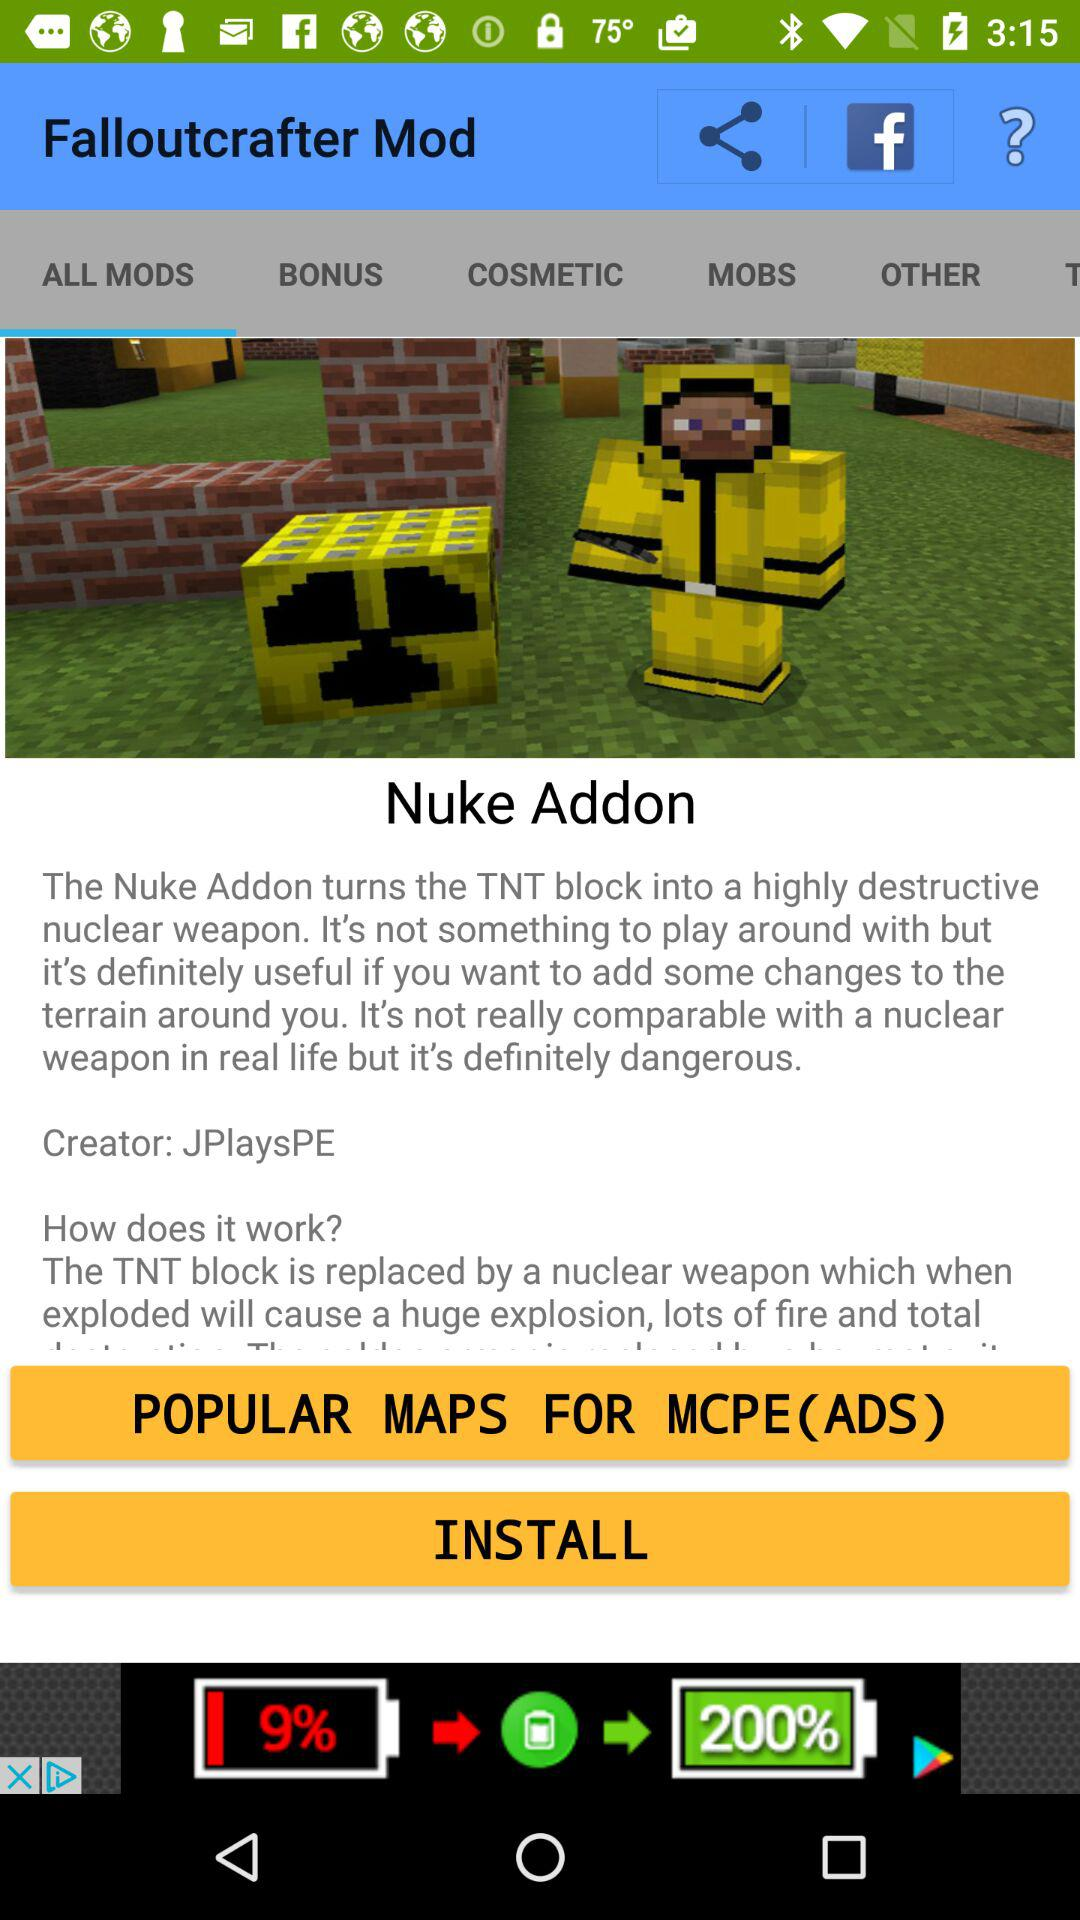Which tab is selected? The tab "ALL MODS" is selected. 